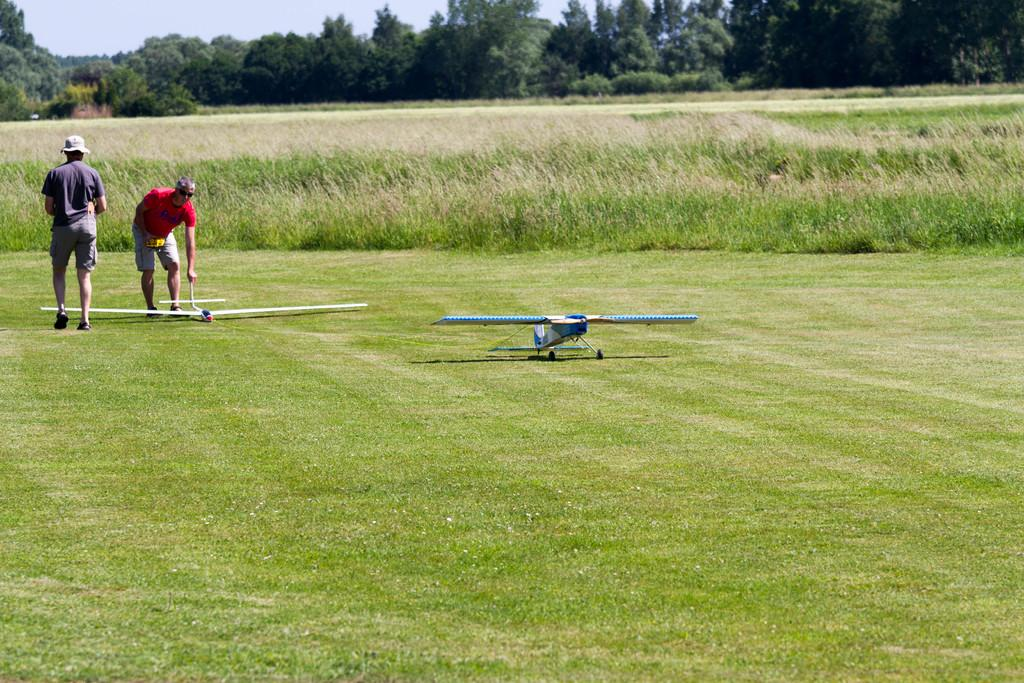How many people are present in the image? There are two people in the image. What else can be seen in the image besides the people? There are planes, grass, plants, and trees in the image. What is visible in the background of the image? The sky is visible in the background of the image. What type of waste can be seen in the image? There is no waste present in the image. What kind of surprise is happening in the image? There is no surprise depicted in the image. 